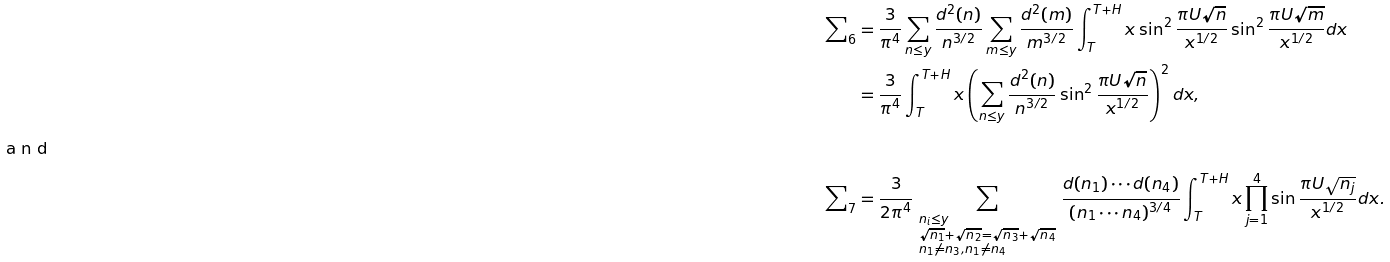<formula> <loc_0><loc_0><loc_500><loc_500>\sum \nolimits _ { 6 } & = \frac { 3 } { \pi ^ { 4 } } \sum _ { n \leq y } \frac { d ^ { 2 } ( n ) } { n ^ { 3 / 2 } } \sum _ { m \leq y } \frac { d ^ { 2 } ( m ) } { m ^ { 3 / 2 } } \int _ { T } ^ { T + H } x \sin ^ { 2 } \frac { \pi U \sqrt { n } } { x ^ { 1 / 2 } } \sin ^ { 2 } \frac { \pi U \sqrt { m } } { x ^ { 1 / 2 } } d x \\ & = \frac { 3 } { \pi ^ { 4 } } \int _ { T } ^ { T + H } x \left ( \sum _ { n \leq y } \frac { d ^ { 2 } ( n ) } { n ^ { 3 / 2 } } \sin ^ { 2 } \frac { \pi U \sqrt { n } } { x ^ { 1 / 2 } } \right ) ^ { 2 } d x , \\ \intertext { a n d } \sum \nolimits _ { 7 } & = \frac { 3 } { 2 \pi ^ { 4 } } \, \sum _ { \begin{subarray} { c } n _ { i } \leq y \\ \sqrt { n _ { 1 } } + \sqrt { n _ { 2 } } = \sqrt { n _ { 3 } } + \sqrt { n _ { 4 } } \\ n _ { 1 } \neq n _ { 3 } , n _ { 1 } \neq n _ { 4 } \end{subarray} } \, \frac { d ( n _ { 1 } ) \cdots d ( n _ { 4 } ) } { ( n _ { 1 } \cdots n _ { 4 } ) ^ { 3 / 4 } } \int _ { T } ^ { T + H } x \prod _ { j = 1 } ^ { 4 } \sin \frac { \pi U \sqrt { n _ { j } } } { x ^ { 1 / 2 } } d x .</formula> 